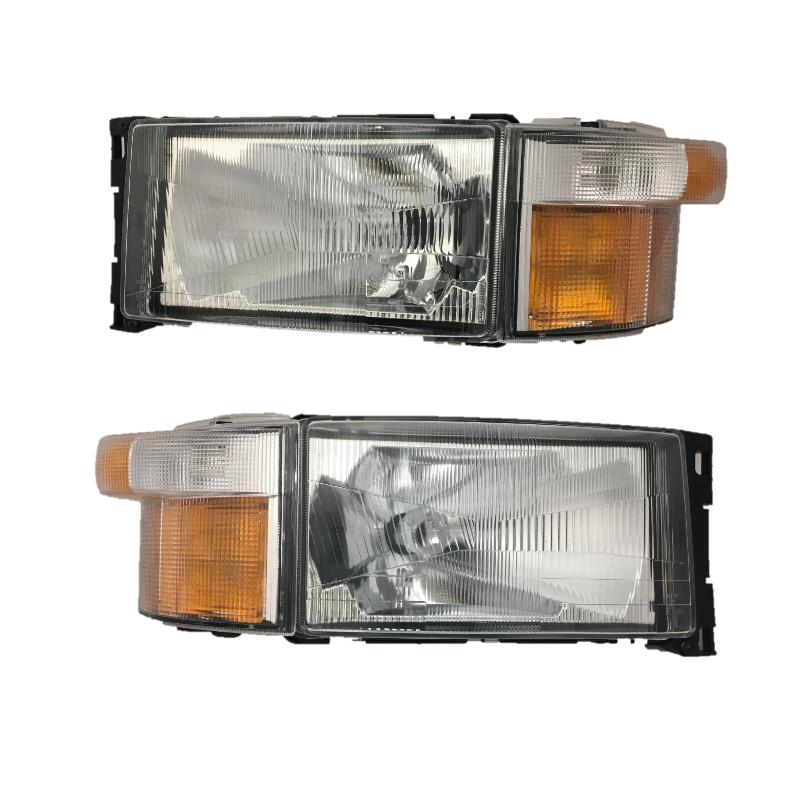Can you tell if these headlamps could be used in vintage or modern vehicles? These headlamps have a design that leans more towards that used in older or vintage vehicles, likely from the late 20th century. The rectangular shape and the presence of separate compartments for the main beam and turn signal are indicative of designs prevalent in the 1980s and 1990s. 